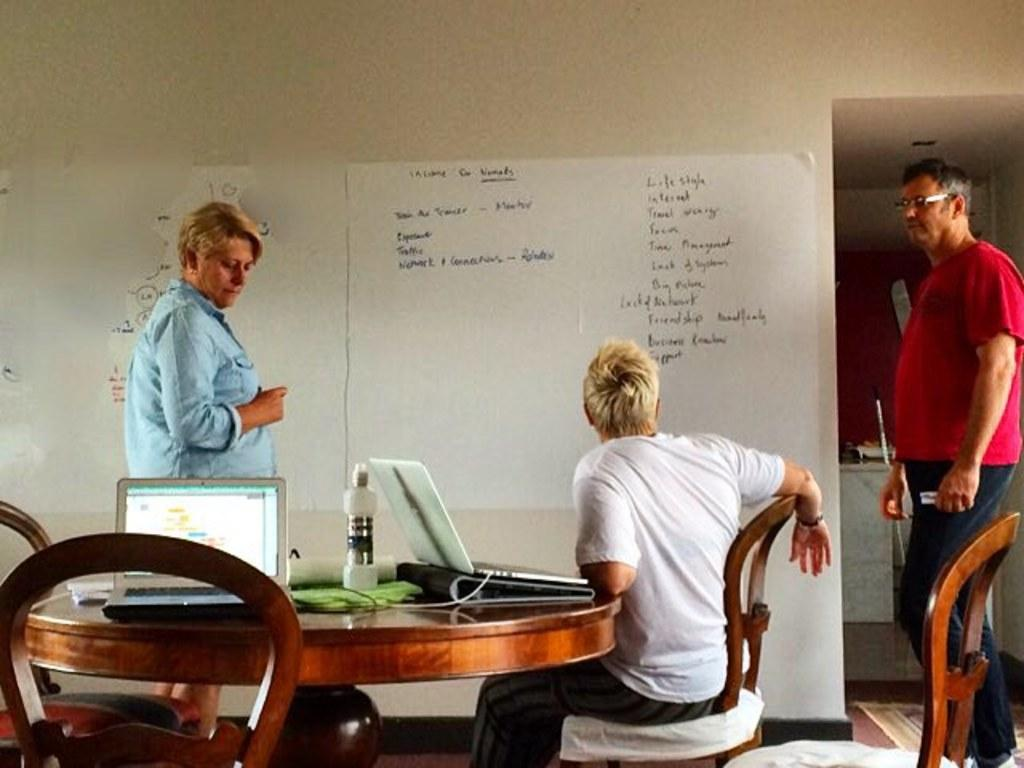How many people are present in the image? There are three people in the image. What is one person doing in the image? One person is sitting in front of a table. What objects can be seen on the table? There are two laptops and a bottle on the table. What is on the wall in the image? There is a board on the wall. What type of cattle can be seen grazing in the background of the image? There is no cattle present in the image; it features three people, a table, two laptops, a bottle, and a board on the wall. What thrilling activity are the people participating in, as seen in the image? The image does not depict any thrilling activities; it shows people sitting in front of a table with laptops and a bottle. 